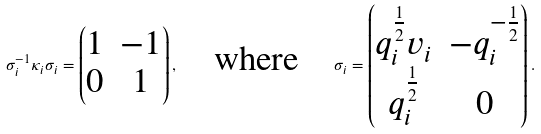Convert formula to latex. <formula><loc_0><loc_0><loc_500><loc_500>\sigma _ { i } ^ { - 1 } \kappa _ { i } \sigma _ { i } = \begin{pmatrix} 1 & - 1 \\ 0 & 1 \end{pmatrix} , \quad \text {where} \quad \sigma _ { i } = \begin{pmatrix} q _ { i } ^ { \frac { 1 } { 2 } } v _ { i } & - q _ { i } ^ { - \frac { 1 } { 2 } } \\ q _ { i } ^ { \frac { 1 } { 2 } } & 0 \end{pmatrix} .</formula> 